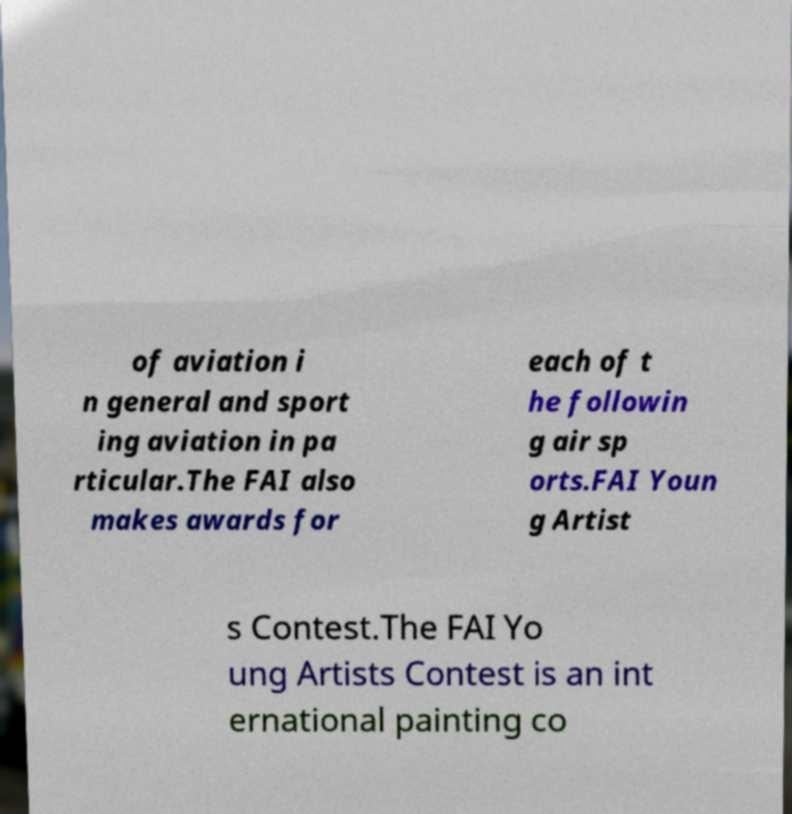Could you assist in decoding the text presented in this image and type it out clearly? of aviation i n general and sport ing aviation in pa rticular.The FAI also makes awards for each of t he followin g air sp orts.FAI Youn g Artist s Contest.The FAI Yo ung Artists Contest is an int ernational painting co 